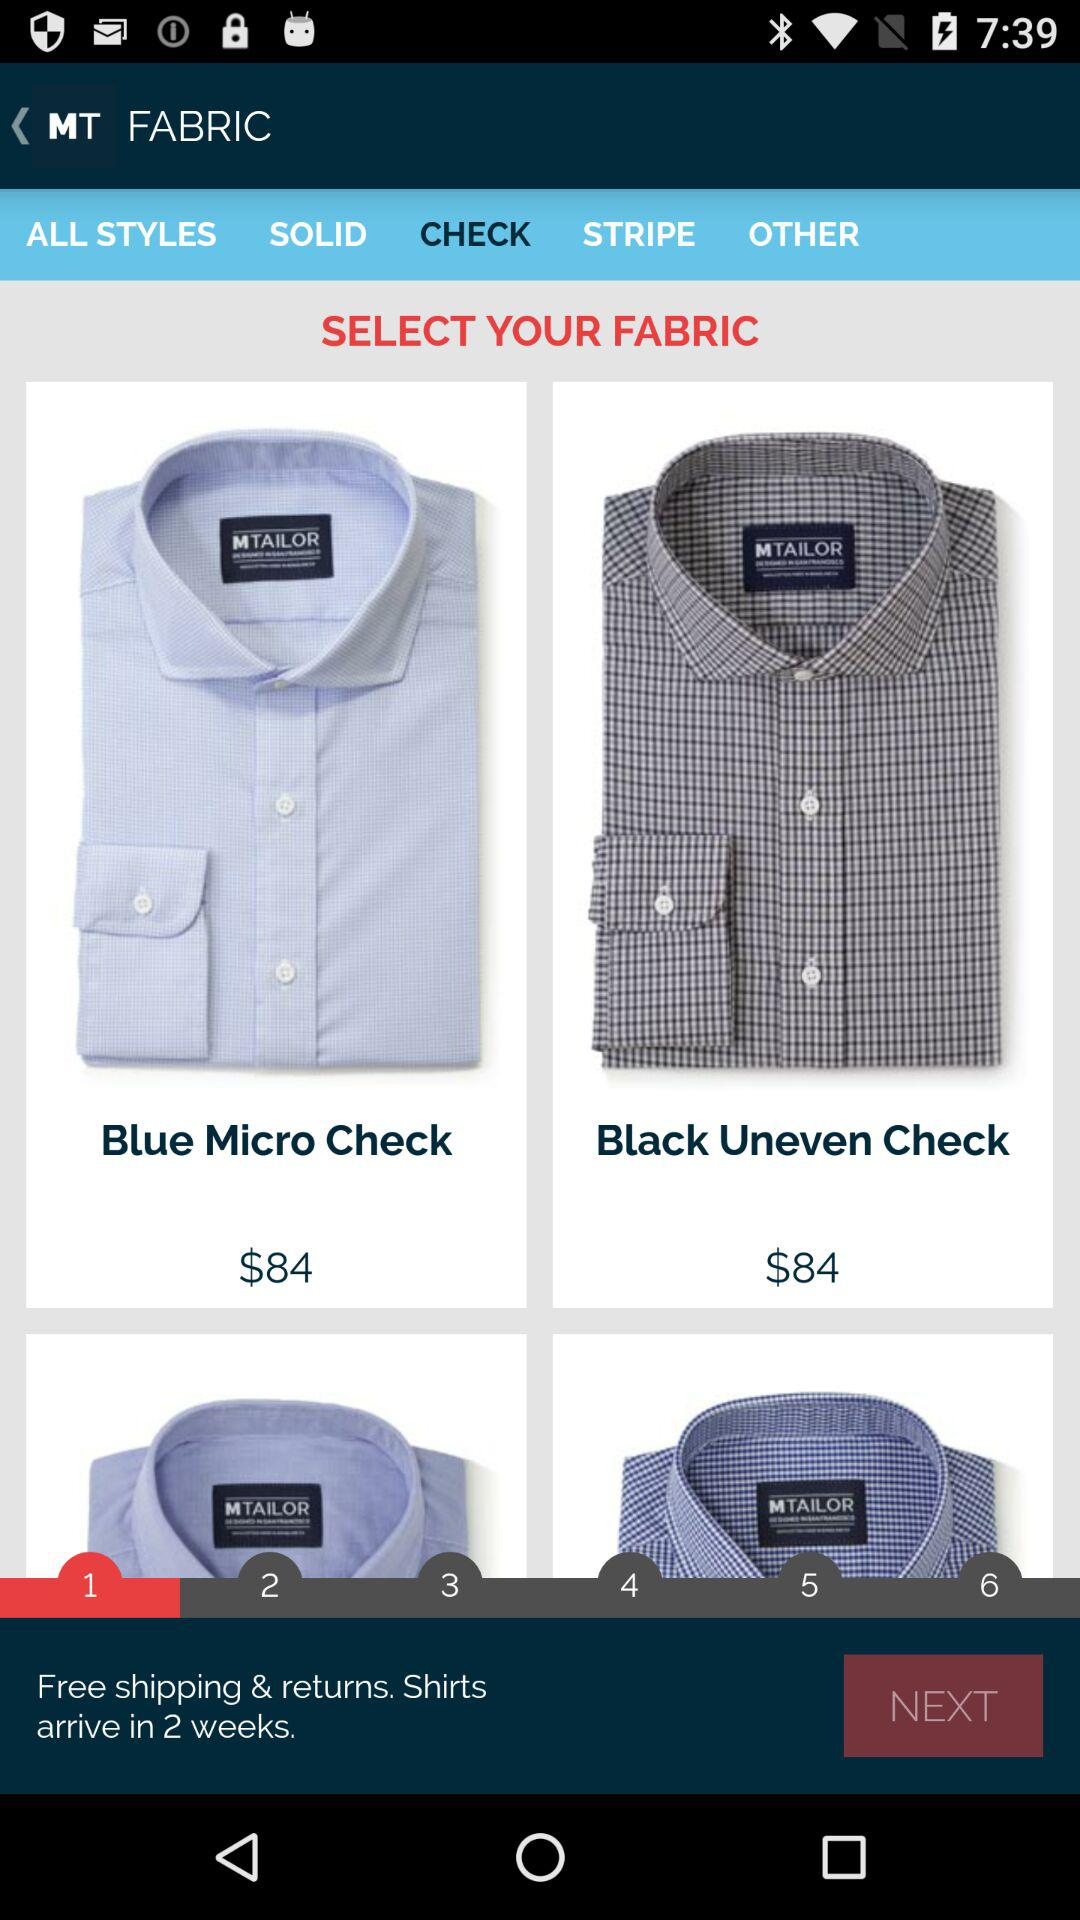Which tab is selected? The selected tab is "CHECK". 